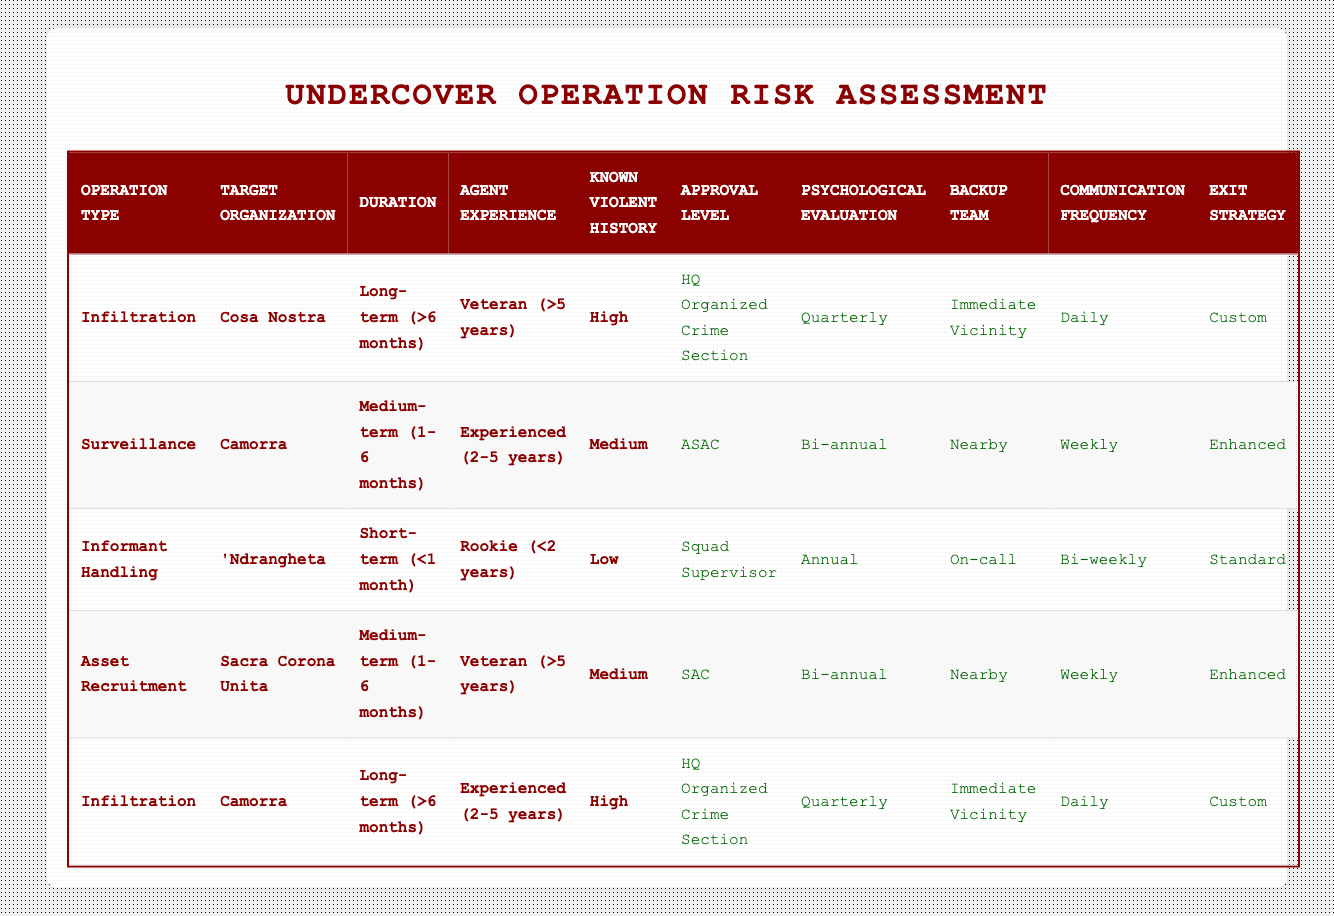What is the approval level for an infiltration operation targeting Cosa Nostra with a veteran agent and high violent history? The table clearly indicates that for the conditions of an infiltration operation, targeting Cosa Nostra, with a veteran agent, and a high level of violent history, the approval level is "HQ Organized Crime Section."
Answer: HQ Organized Crime Section How often is psychological evaluation required for surveillance operations targeting the Camorra with medium violent history? By looking at the rules, a surveillance operation targeting the Camorra with medium violent history requires a psychological evaluation that is conducted bi-annually.
Answer: Bi-annual Is the backup team required for informant handling with a rookie agent and low violent history? In the case of informant handling, the table states that for a rookie agent and low violent history, a backup team is on-call, meaning it is required but not always present.
Answer: Yes Which exit strategy is applied to asset recruitment involving Sacra Corona Unita with a veteran agent and medium violent history? The conditions outlined for asset recruitment involving Sacra Corona Unita with a veteran agent and medium violent history indicate that the exit strategy is "Enhanced."
Answer: Enhanced How many operations in the table require a psychological evaluation of quarterly frequency? In total, two operations require a psychological evaluation of quarterly frequency: both infiltration operations for Cosa Nostra and Camorra with specific conditions.
Answer: 2 If the operation type is surveillance, targeting Camorra, with an experienced agent for a medium-term duration, what is the communication frequency? For the specified conditions of a surveillance operation targeting the Camorra, with an experienced agent and medium-term duration, the communication frequency is weekly.
Answer: Weekly Do any operations targeting the 'Ndrangheta require quarterly psychological evaluations? When examining the rules, there are no operations involving the 'Ndrangheta that specify quarterly psychological evaluations; the informant handling for 'Ndrangheta requires only annual evaluations.
Answer: No What is the average duration of the operations listed in the table? The durations listed include short-term, medium-term, and long-term. Converting them to months gives an average: (0.5 + 3.5 + 6 + 6) / 4 = 4.25 months average duration.
Answer: 4.25 months How does the agent experience level affect the required backup team for infiltrations in long-term scenarios? None of the infiltrations in long-term scenarios require backup teams. Specifically, both entries for infiltration in the table specify "Immediate Vicinity," which shows variation but doesn't require a separate backup team as per the existing conditions.
Answer: Yes 